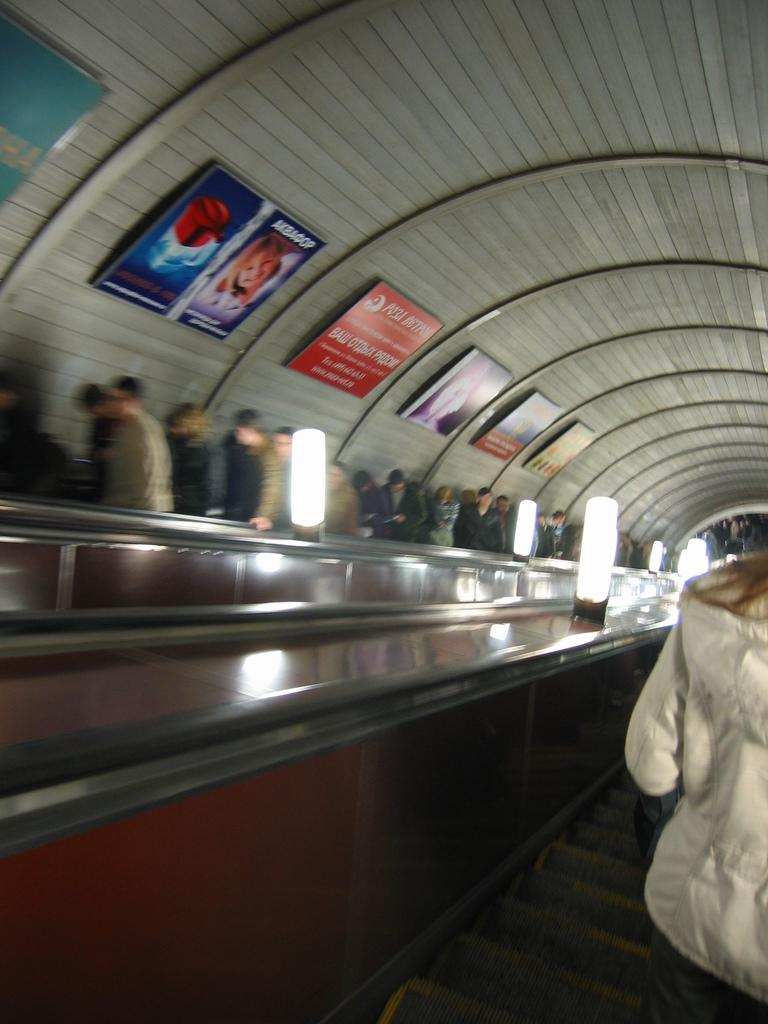Who is on the right side of the image? There is a person on the right side of the image. What is located beside the person? There are lights arranged beside the person. What can be seen in the background of the image? There are people and posters attached to the roof in the background. What type of steel is used to construct the hill in the image? There is no hill present in the image, and therefore no steel construction can be observed. How old is the person's daughter in the image? There is no mention of a daughter in the image, so it is impossible to determine her age. 